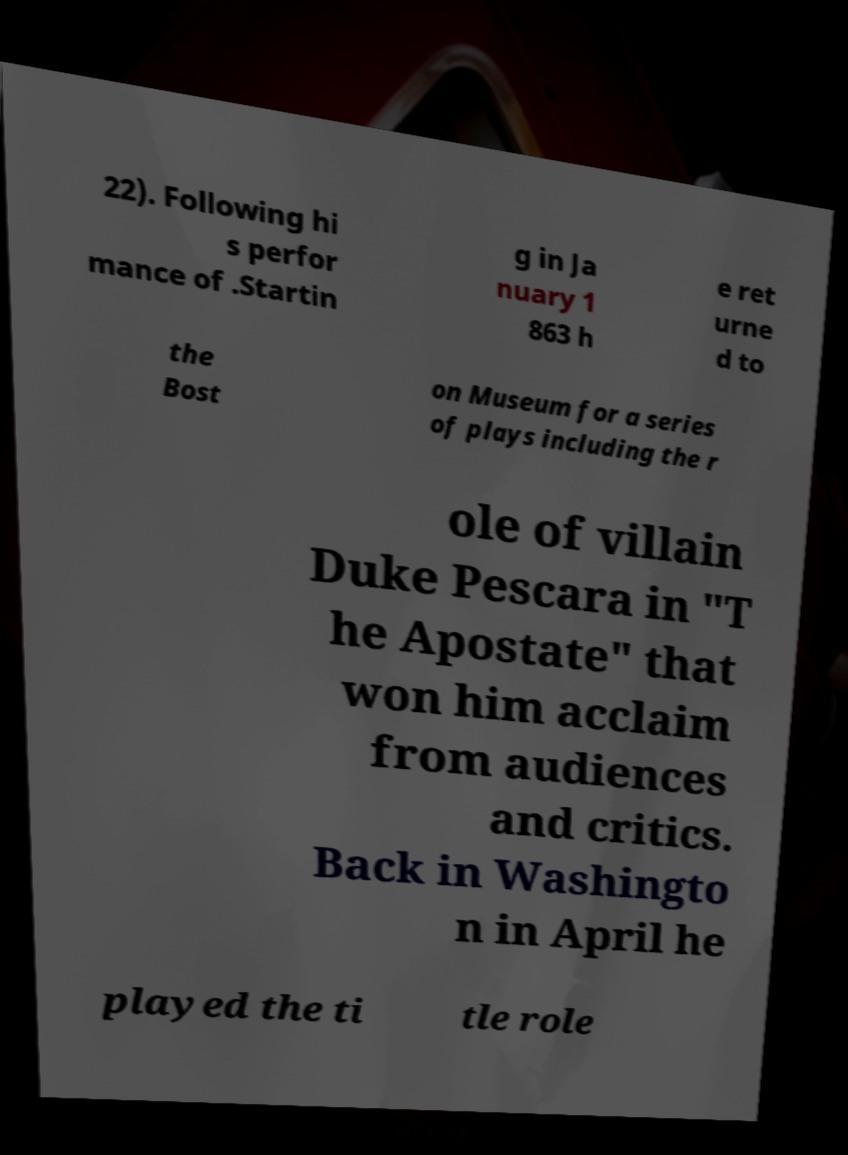Can you read and provide the text displayed in the image?This photo seems to have some interesting text. Can you extract and type it out for me? 22). Following hi s perfor mance of .Startin g in Ja nuary 1 863 h e ret urne d to the Bost on Museum for a series of plays including the r ole of villain Duke Pescara in "T he Apostate" that won him acclaim from audiences and critics. Back in Washingto n in April he played the ti tle role 